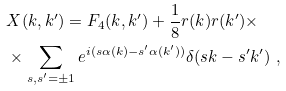Convert formula to latex. <formula><loc_0><loc_0><loc_500><loc_500>& X ( k , k ^ { \prime } ) = F _ { 4 } ( k , k ^ { \prime } ) + \frac { 1 } { 8 } r ( k ) r ( k ^ { \prime } ) \times \\ & \times \sum _ { s , s ^ { \prime } = \pm 1 } e ^ { i ( s \alpha ( k ) - s ^ { \prime } \alpha ( k ^ { \prime } ) ) } \delta ( s k - s ^ { \prime } k ^ { \prime } ) \ ,</formula> 